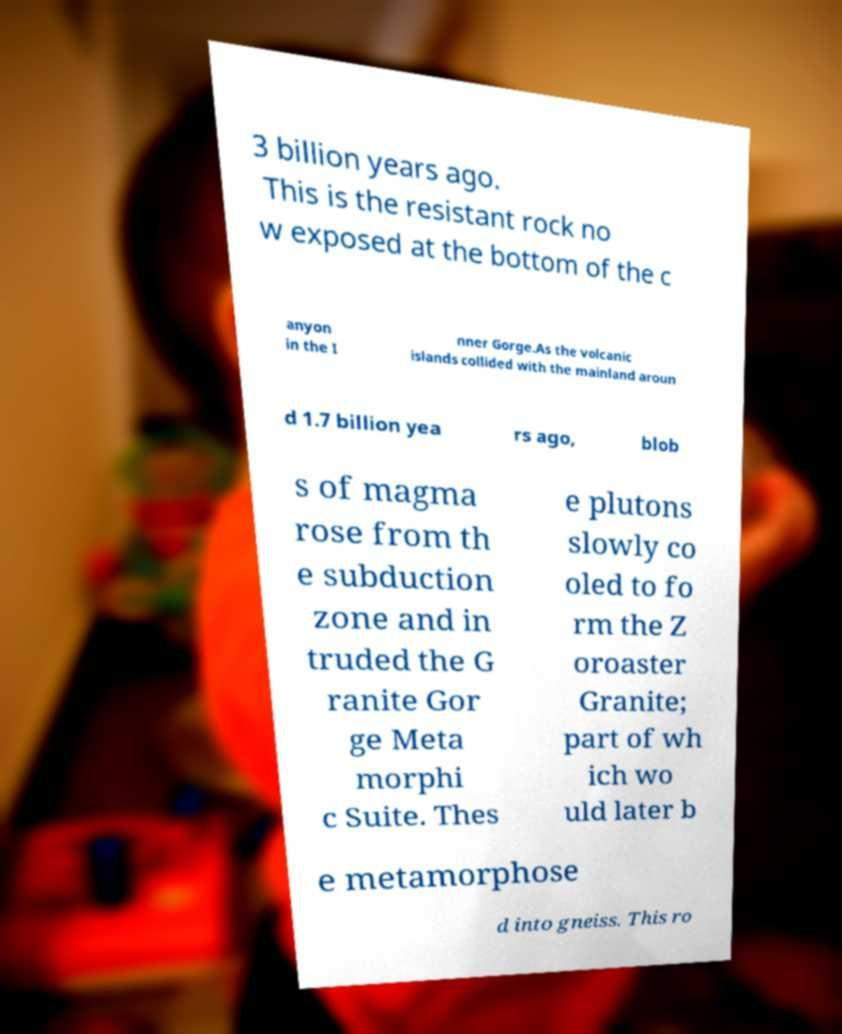What messages or text are displayed in this image? I need them in a readable, typed format. 3 billion years ago. This is the resistant rock no w exposed at the bottom of the c anyon in the I nner Gorge.As the volcanic islands collided with the mainland aroun d 1.7 billion yea rs ago, blob s of magma rose from th e subduction zone and in truded the G ranite Gor ge Meta morphi c Suite. Thes e plutons slowly co oled to fo rm the Z oroaster Granite; part of wh ich wo uld later b e metamorphose d into gneiss. This ro 